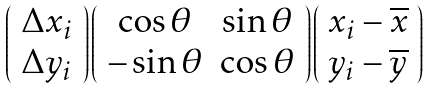<formula> <loc_0><loc_0><loc_500><loc_500>\left ( \begin{array} { c } \Delta x _ { i } \\ \Delta y _ { i } \\ \end{array} \right ) \left ( \begin{array} { c c } \cos \theta & \sin \theta \\ - \sin \theta & \cos \theta \\ \end{array} \right ) \left ( \begin{array} { c } x _ { i } - \overline { x } \\ y _ { i } - \overline { y } \\ \end{array} \right )</formula> 